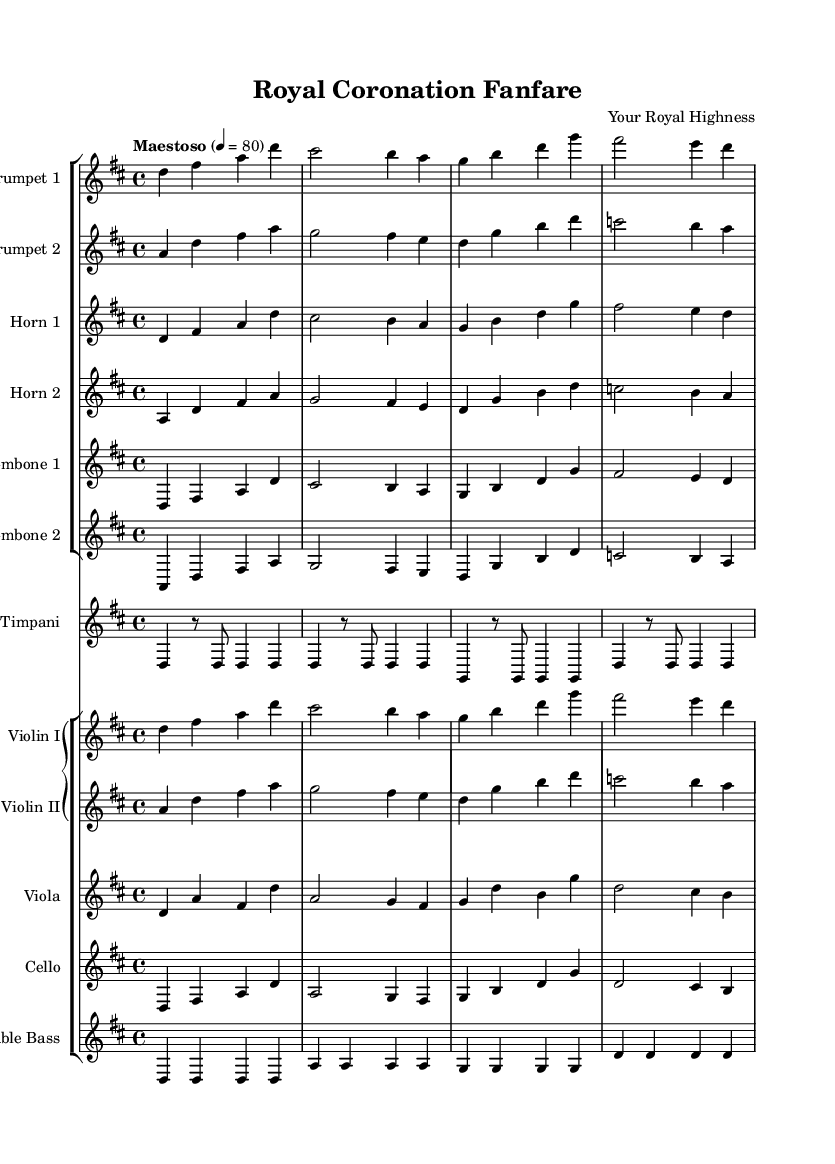What is the key signature of this music? The key signature is indicated at the beginning of the score and shows two sharps (F# and C#), which signifies D major.
Answer: D major What is the time signature of this music? The time signature appears at the beginning of the score, represented by the fraction 4/4, indicating four beats per measure with a quarter note receiving one beat.
Answer: 4/4 What is the tempo marking of this piece? The tempo marking, located below the title, is indicated as "Maestoso," which signifies a majestic and dignified tempo.
Answer: Maestoso How many instruments are indicated in the score? By counting the different staves in the score, there are a total of 10 instruments, as each staff represents a different instrument or voice.
Answer: 10 Which brass instruments are featured in this composition? The score includes trumpets, horns, and trombones, which are all categorized as brass instruments in orchestral compositions.
Answer: Trumpets, horns, trombones What is the role of the timpani in this piece? The timpani is crucial for emphasizing the underlying rhythm and adding a dramatic effect in orchestral arrangements, particularly in royal ceremonies.
Answer: Emphasize rhythm What section does the cello belong to in this arrangement? The cello is notated in the lower staff within the Grand Staff, indicating it belongs to the string section.
Answer: String section 